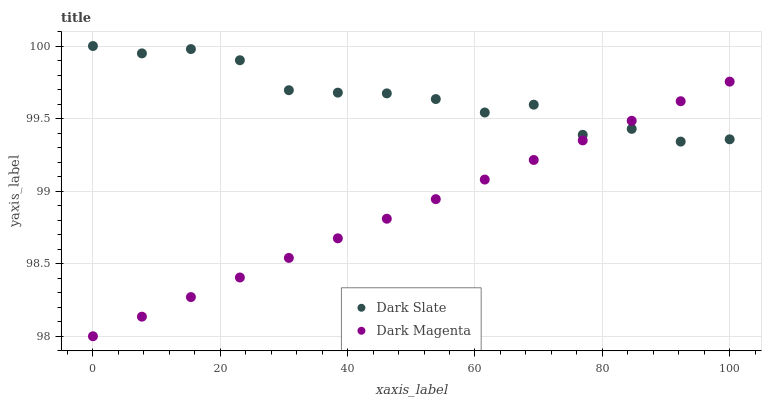Does Dark Magenta have the minimum area under the curve?
Answer yes or no. Yes. Does Dark Slate have the maximum area under the curve?
Answer yes or no. Yes. Does Dark Magenta have the maximum area under the curve?
Answer yes or no. No. Is Dark Magenta the smoothest?
Answer yes or no. Yes. Is Dark Slate the roughest?
Answer yes or no. Yes. Is Dark Magenta the roughest?
Answer yes or no. No. Does Dark Magenta have the lowest value?
Answer yes or no. Yes. Does Dark Slate have the highest value?
Answer yes or no. Yes. Does Dark Magenta have the highest value?
Answer yes or no. No. Does Dark Magenta intersect Dark Slate?
Answer yes or no. Yes. Is Dark Magenta less than Dark Slate?
Answer yes or no. No. Is Dark Magenta greater than Dark Slate?
Answer yes or no. No. 